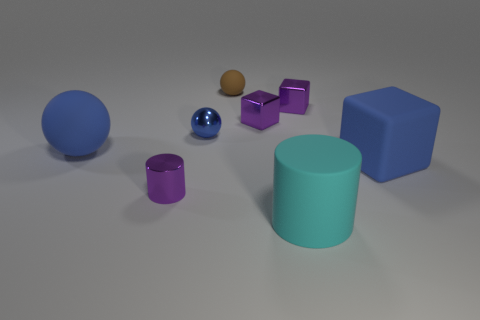Add 1 tiny brown matte balls. How many objects exist? 9 Subtract all blocks. How many objects are left? 5 Add 1 purple shiny things. How many purple shiny things exist? 4 Subtract 1 purple cylinders. How many objects are left? 7 Subtract all blue shiny blocks. Subtract all blue matte objects. How many objects are left? 6 Add 1 blue spheres. How many blue spheres are left? 3 